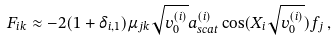Convert formula to latex. <formula><loc_0><loc_0><loc_500><loc_500>F _ { i k } \approx - 2 ( 1 + \delta _ { i , 1 } ) \mu _ { j k } \sqrt { v _ { 0 } ^ { ( i ) } } a _ { s c a t } ^ { ( i ) } \cos ( X _ { i } \sqrt { v _ { 0 } ^ { ( i ) } } ) f _ { j } \, ,</formula> 